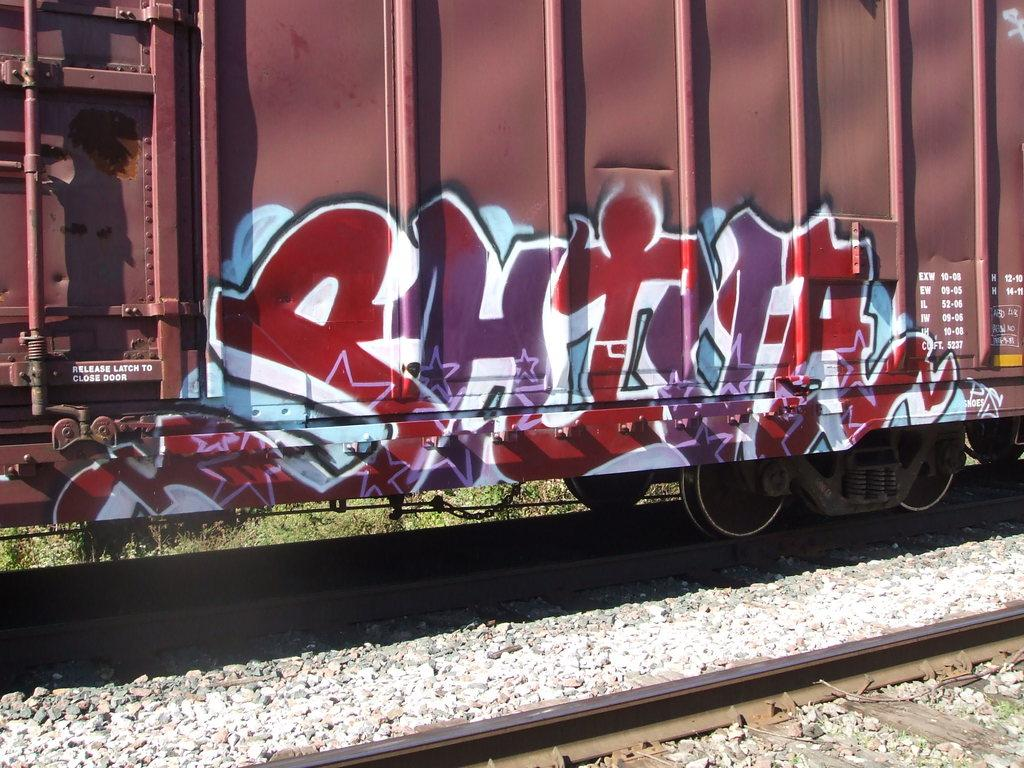What is the main subject of the image? The main subject of the image is a train. What is the train's location in the image? The train is on a track in the image. Are there any additional features on the train? Yes, there is graffiti on the train. What type of natural environment is visible in the image? There is grass visible in the image. What type of material is present in the image? There are stones in the image. What type of hair can be seen on the train in the image? There is no hair present on the train in the image; it is a train with graffiti on it. 